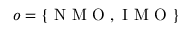Convert formula to latex. <formula><loc_0><loc_0><loc_500><loc_500>o = \{ N M O , I M O \}</formula> 